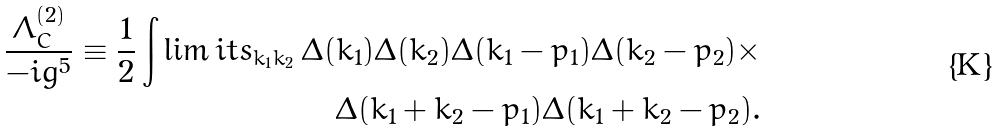<formula> <loc_0><loc_0><loc_500><loc_500>\frac { \Lambda _ { C } ^ { ( 2 ) } } { - i g ^ { 5 } } \equiv \frac { 1 } { 2 } \int \lim i t s _ { k _ { 1 } k _ { 2 } } \, \Delta ( k _ { 1 } ) \Delta ( k _ { 2 } ) \Delta ( k _ { 1 } - p _ { 1 } ) \Delta ( k _ { 2 } - p _ { 2 } ) \times \\ \Delta ( k _ { 1 } + k _ { 2 } - p _ { 1 } ) \Delta ( k _ { 1 } + k _ { 2 } - p _ { 2 } ) .</formula> 